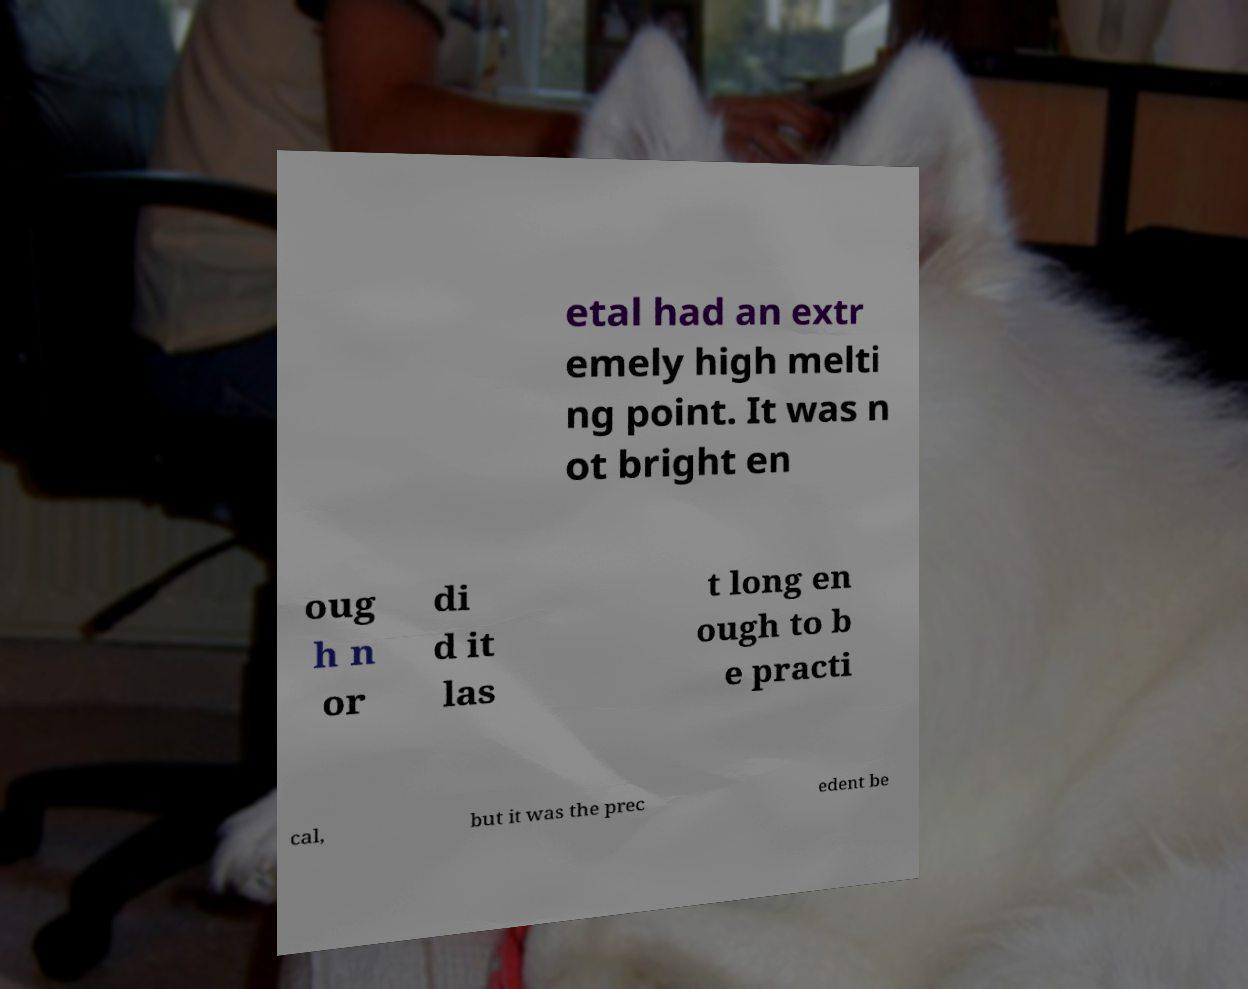Could you assist in decoding the text presented in this image and type it out clearly? etal had an extr emely high melti ng point. It was n ot bright en oug h n or di d it las t long en ough to b e practi cal, but it was the prec edent be 